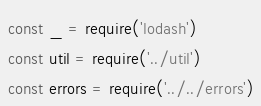<code> <loc_0><loc_0><loc_500><loc_500><_JavaScript_>const _ = require('lodash')
const util = require('../util')
const errors = require('../../errors')
</code> 